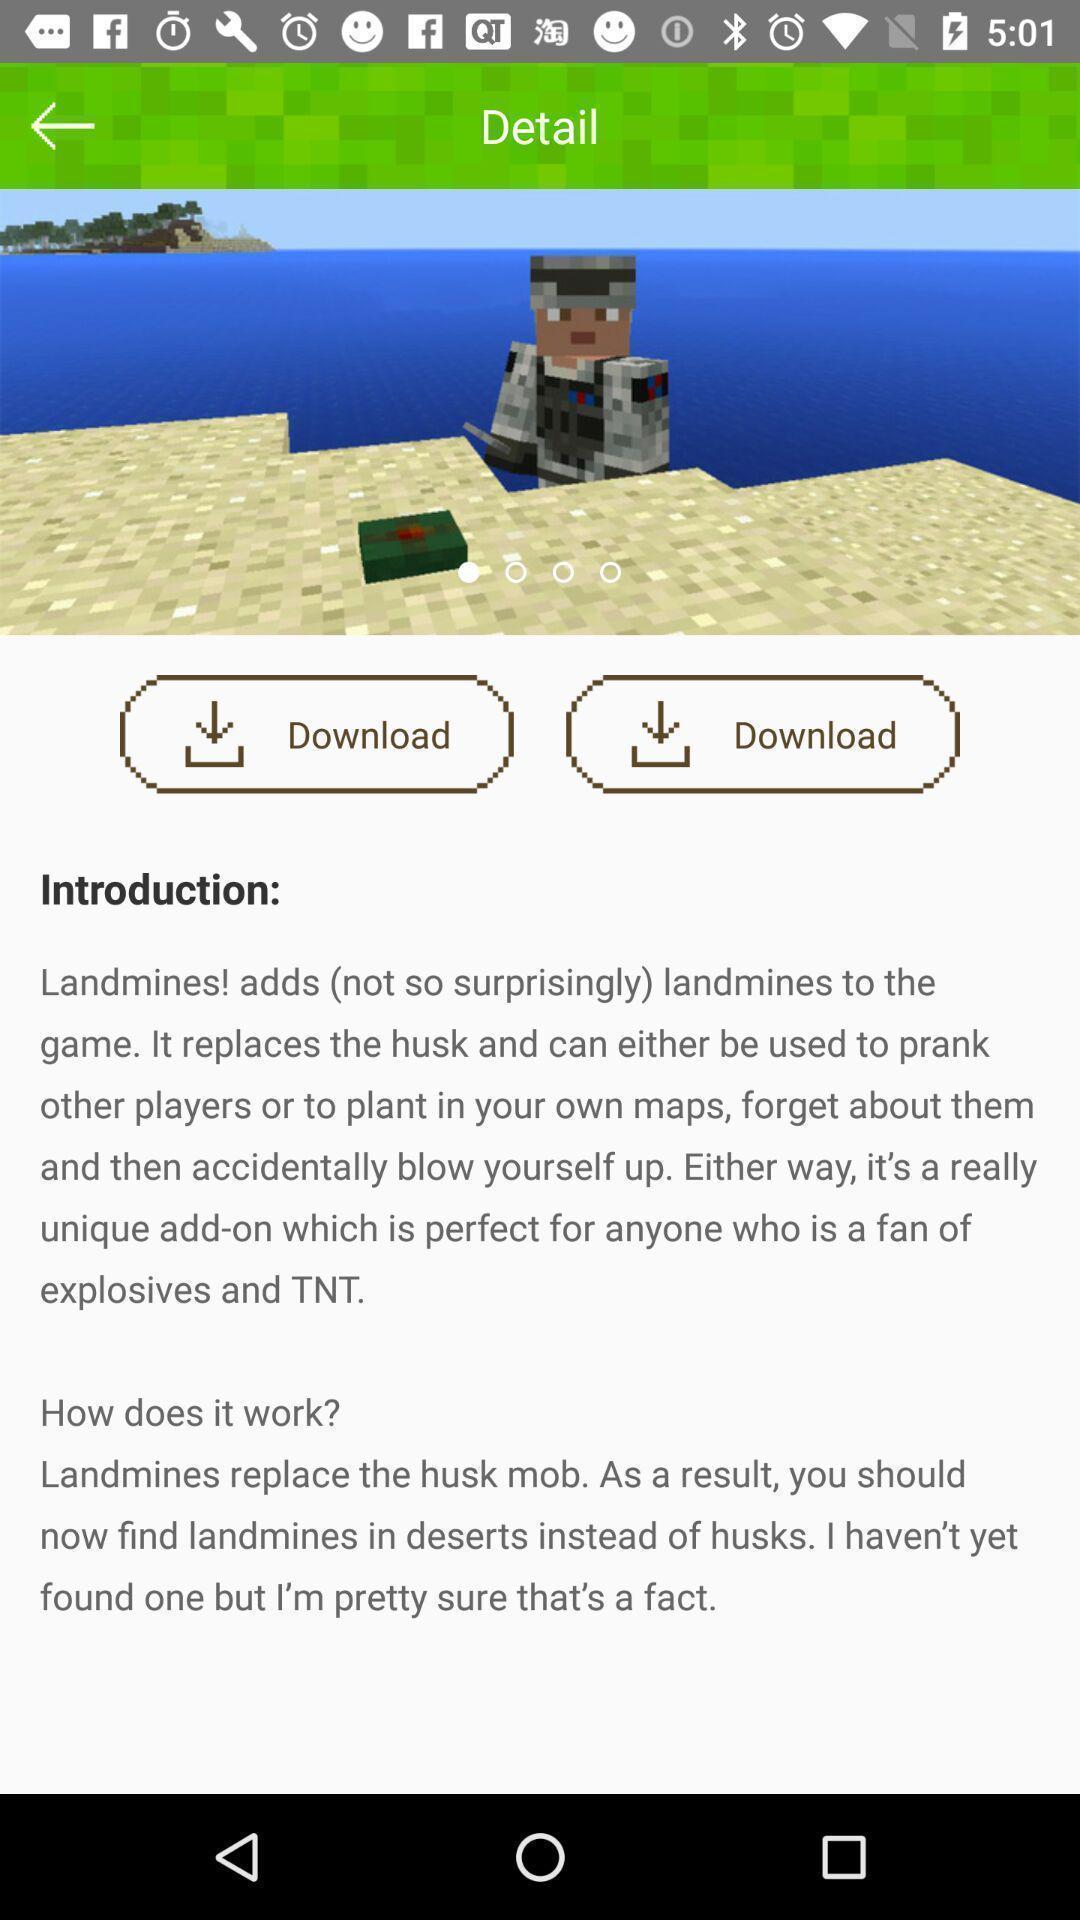Tell me what you see in this picture. Page showing instructions about the game app. 